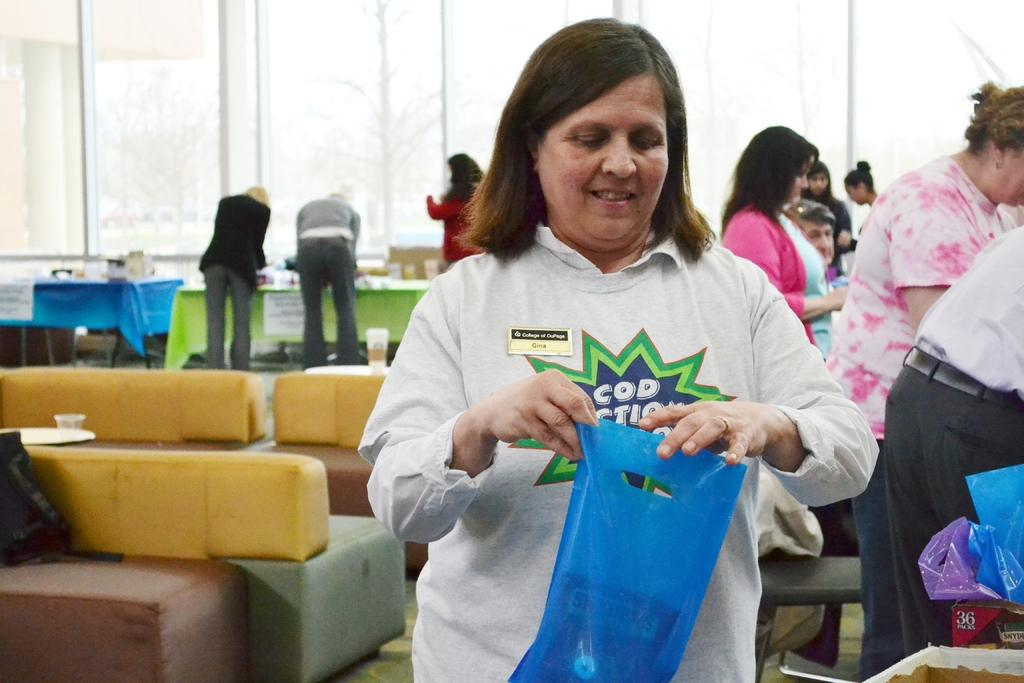What is the woman holding in the image? The woman is holding a plastic bag. What can be seen in the background of the image? There are people, tables, glass windows, couches, and plastic bags in the background. What is on the tables in the background? Posters are on the tables in the background. What type of badge is the woman wearing in the image? There is no badge visible on the woman in the image. What kind of haircut does the man in the background have? There is no information about the haircuts of the people in the background. Where is the mailbox located in the image? There is no mailbox present in the image. 